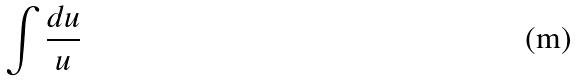Convert formula to latex. <formula><loc_0><loc_0><loc_500><loc_500>\int \frac { d u } { u }</formula> 